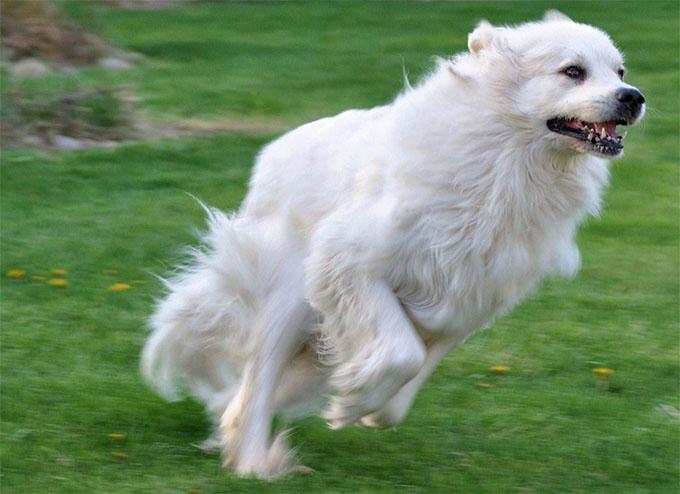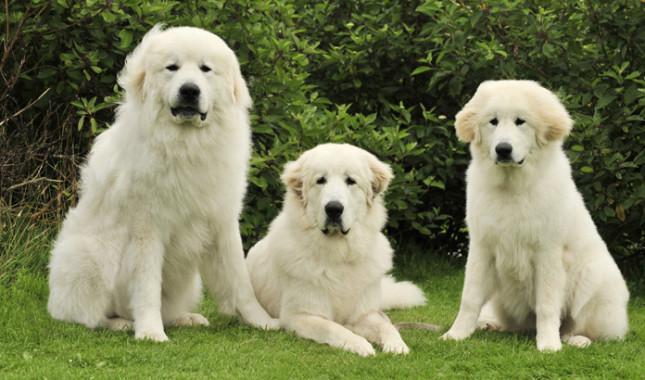The first image is the image on the left, the second image is the image on the right. For the images displayed, is the sentence "Right image shows an older person next to a large dog." factually correct? Answer yes or no. No. The first image is the image on the left, the second image is the image on the right. Examine the images to the left and right. Is the description "There are at least 3 dogs." accurate? Answer yes or no. Yes. 